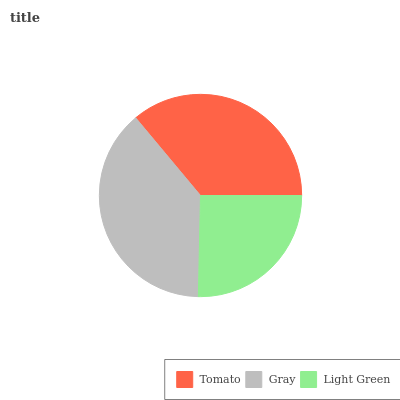Is Light Green the minimum?
Answer yes or no. Yes. Is Gray the maximum?
Answer yes or no. Yes. Is Gray the minimum?
Answer yes or no. No. Is Light Green the maximum?
Answer yes or no. No. Is Gray greater than Light Green?
Answer yes or no. Yes. Is Light Green less than Gray?
Answer yes or no. Yes. Is Light Green greater than Gray?
Answer yes or no. No. Is Gray less than Light Green?
Answer yes or no. No. Is Tomato the high median?
Answer yes or no. Yes. Is Tomato the low median?
Answer yes or no. Yes. Is Gray the high median?
Answer yes or no. No. Is Light Green the low median?
Answer yes or no. No. 